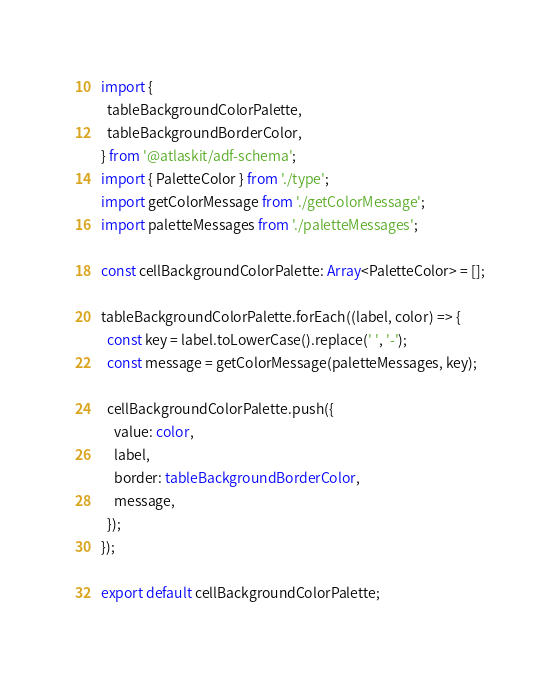Convert code to text. <code><loc_0><loc_0><loc_500><loc_500><_TypeScript_>import {
  tableBackgroundColorPalette,
  tableBackgroundBorderColor,
} from '@atlaskit/adf-schema';
import { PaletteColor } from './type';
import getColorMessage from './getColorMessage';
import paletteMessages from './paletteMessages';

const cellBackgroundColorPalette: Array<PaletteColor> = [];

tableBackgroundColorPalette.forEach((label, color) => {
  const key = label.toLowerCase().replace(' ', '-');
  const message = getColorMessage(paletteMessages, key);

  cellBackgroundColorPalette.push({
    value: color,
    label,
    border: tableBackgroundBorderColor,
    message,
  });
});

export default cellBackgroundColorPalette;
</code> 